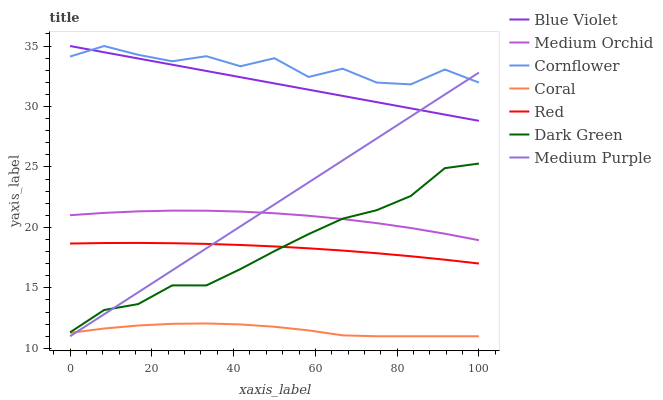Does Coral have the minimum area under the curve?
Answer yes or no. Yes. Does Cornflower have the maximum area under the curve?
Answer yes or no. Yes. Does Medium Orchid have the minimum area under the curve?
Answer yes or no. No. Does Medium Orchid have the maximum area under the curve?
Answer yes or no. No. Is Medium Purple the smoothest?
Answer yes or no. Yes. Is Cornflower the roughest?
Answer yes or no. Yes. Is Coral the smoothest?
Answer yes or no. No. Is Coral the roughest?
Answer yes or no. No. Does Coral have the lowest value?
Answer yes or no. Yes. Does Medium Orchid have the lowest value?
Answer yes or no. No. Does Blue Violet have the highest value?
Answer yes or no. Yes. Does Medium Orchid have the highest value?
Answer yes or no. No. Is Dark Green less than Blue Violet?
Answer yes or no. Yes. Is Medium Orchid greater than Red?
Answer yes or no. Yes. Does Cornflower intersect Medium Purple?
Answer yes or no. Yes. Is Cornflower less than Medium Purple?
Answer yes or no. No. Is Cornflower greater than Medium Purple?
Answer yes or no. No. Does Dark Green intersect Blue Violet?
Answer yes or no. No. 